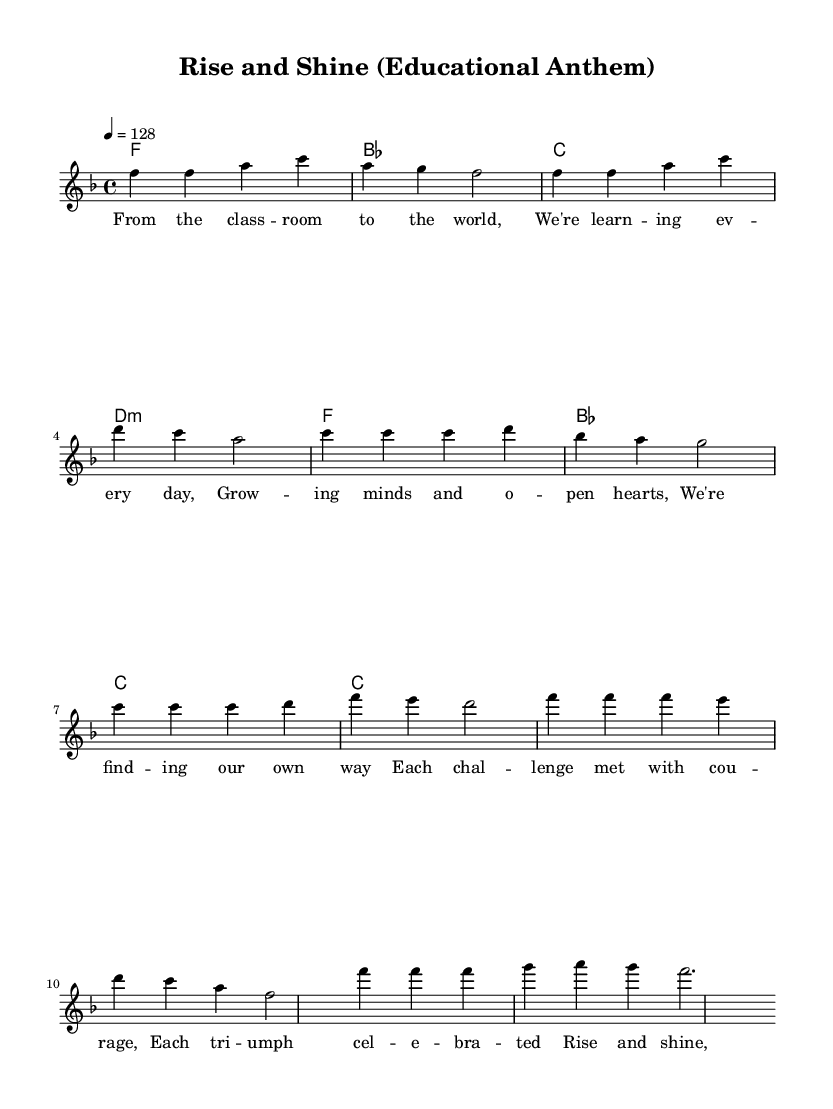What is the key signature of this music? The key signature indicated is F major, which has one flat (B flat).
Answer: F major What is the time signature of this music? The time signature shown is 4/4, which means there are four beats in each measure.
Answer: 4/4 What is the tempo marking for this piece? The tempo marking states 4 = 128, which indicates the beats per minute for the music.
Answer: 128 How many measures are in the verse section? The verse section consists of two groups of four beats; there are four measures total.
Answer: Four What is the first lyric of the chorus? The first lyric of the chorus is “Rise and shine”, which leads off the section.
Answer: Rise and shine In what style does this anthem most prominently fit? The anthem is characterized by its soulful vocal lines, typical of the house music genre that aims to celebrate personal and educational growth.
Answer: Soulful vocal house 